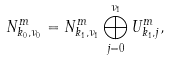Convert formula to latex. <formula><loc_0><loc_0><loc_500><loc_500>N _ { k _ { 0 } , \nu _ { 0 } } ^ { m } = N _ { k _ { 1 } , \nu _ { 1 } } ^ { m } \bigoplus _ { j = 0 } ^ { \nu _ { 1 } } U _ { k _ { 1 } , j } ^ { m } ,</formula> 